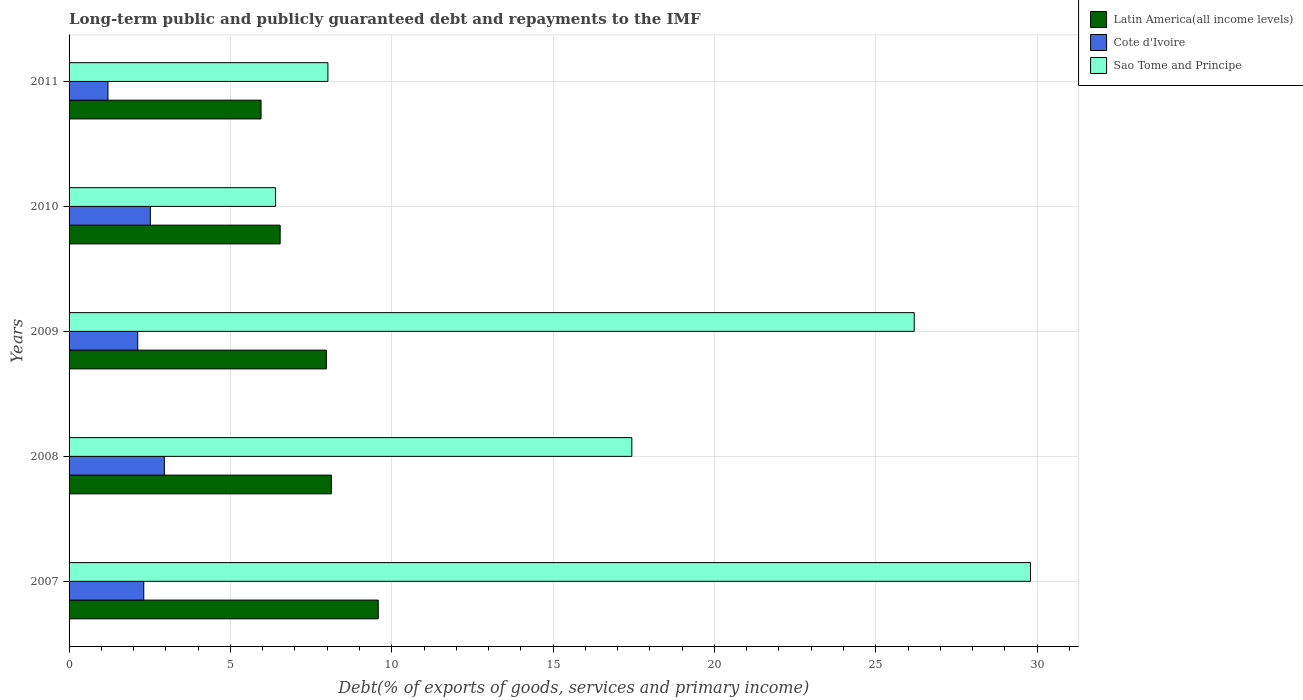How many different coloured bars are there?
Your answer should be very brief. 3. Are the number of bars per tick equal to the number of legend labels?
Provide a succinct answer. Yes. Are the number of bars on each tick of the Y-axis equal?
Provide a short and direct response. Yes. How many bars are there on the 2nd tick from the top?
Offer a very short reply. 3. How many bars are there on the 3rd tick from the bottom?
Ensure brevity in your answer.  3. What is the label of the 1st group of bars from the top?
Provide a succinct answer. 2011. In how many cases, is the number of bars for a given year not equal to the number of legend labels?
Offer a very short reply. 0. What is the debt and repayments in Sao Tome and Principe in 2009?
Make the answer very short. 26.19. Across all years, what is the maximum debt and repayments in Sao Tome and Principe?
Your response must be concise. 29.8. Across all years, what is the minimum debt and repayments in Cote d'Ivoire?
Provide a short and direct response. 1.21. In which year was the debt and repayments in Cote d'Ivoire maximum?
Offer a very short reply. 2008. In which year was the debt and repayments in Cote d'Ivoire minimum?
Your response must be concise. 2011. What is the total debt and repayments in Cote d'Ivoire in the graph?
Ensure brevity in your answer.  11.12. What is the difference between the debt and repayments in Latin America(all income levels) in 2007 and that in 2011?
Make the answer very short. 3.63. What is the difference between the debt and repayments in Latin America(all income levels) in 2009 and the debt and repayments in Cote d'Ivoire in 2007?
Ensure brevity in your answer.  5.66. What is the average debt and repayments in Cote d'Ivoire per year?
Keep it short and to the point. 2.22. In the year 2007, what is the difference between the debt and repayments in Cote d'Ivoire and debt and repayments in Sao Tome and Principe?
Ensure brevity in your answer.  -27.48. What is the ratio of the debt and repayments in Cote d'Ivoire in 2009 to that in 2011?
Provide a short and direct response. 1.77. Is the debt and repayments in Cote d'Ivoire in 2009 less than that in 2011?
Provide a short and direct response. No. What is the difference between the highest and the second highest debt and repayments in Sao Tome and Principe?
Ensure brevity in your answer.  3.6. What is the difference between the highest and the lowest debt and repayments in Latin America(all income levels)?
Your response must be concise. 3.63. What does the 2nd bar from the top in 2011 represents?
Keep it short and to the point. Cote d'Ivoire. What does the 3rd bar from the bottom in 2011 represents?
Your answer should be compact. Sao Tome and Principe. Is it the case that in every year, the sum of the debt and repayments in Sao Tome and Principe and debt and repayments in Latin America(all income levels) is greater than the debt and repayments in Cote d'Ivoire?
Give a very brief answer. Yes. How many years are there in the graph?
Offer a very short reply. 5. Does the graph contain grids?
Offer a terse response. Yes. How many legend labels are there?
Provide a short and direct response. 3. What is the title of the graph?
Offer a terse response. Long-term public and publicly guaranteed debt and repayments to the IMF. What is the label or title of the X-axis?
Ensure brevity in your answer.  Debt(% of exports of goods, services and primary income). What is the Debt(% of exports of goods, services and primary income) of Latin America(all income levels) in 2007?
Keep it short and to the point. 9.58. What is the Debt(% of exports of goods, services and primary income) in Cote d'Ivoire in 2007?
Keep it short and to the point. 2.31. What is the Debt(% of exports of goods, services and primary income) of Sao Tome and Principe in 2007?
Your answer should be compact. 29.8. What is the Debt(% of exports of goods, services and primary income) of Latin America(all income levels) in 2008?
Give a very brief answer. 8.13. What is the Debt(% of exports of goods, services and primary income) of Cote d'Ivoire in 2008?
Keep it short and to the point. 2.95. What is the Debt(% of exports of goods, services and primary income) in Sao Tome and Principe in 2008?
Keep it short and to the point. 17.44. What is the Debt(% of exports of goods, services and primary income) in Latin America(all income levels) in 2009?
Your answer should be compact. 7.97. What is the Debt(% of exports of goods, services and primary income) in Cote d'Ivoire in 2009?
Offer a very short reply. 2.13. What is the Debt(% of exports of goods, services and primary income) in Sao Tome and Principe in 2009?
Your answer should be compact. 26.19. What is the Debt(% of exports of goods, services and primary income) in Latin America(all income levels) in 2010?
Ensure brevity in your answer.  6.54. What is the Debt(% of exports of goods, services and primary income) in Cote d'Ivoire in 2010?
Provide a short and direct response. 2.52. What is the Debt(% of exports of goods, services and primary income) of Sao Tome and Principe in 2010?
Keep it short and to the point. 6.4. What is the Debt(% of exports of goods, services and primary income) in Latin America(all income levels) in 2011?
Your response must be concise. 5.95. What is the Debt(% of exports of goods, services and primary income) in Cote d'Ivoire in 2011?
Keep it short and to the point. 1.21. What is the Debt(% of exports of goods, services and primary income) in Sao Tome and Principe in 2011?
Provide a short and direct response. 8.02. Across all years, what is the maximum Debt(% of exports of goods, services and primary income) in Latin America(all income levels)?
Keep it short and to the point. 9.58. Across all years, what is the maximum Debt(% of exports of goods, services and primary income) in Cote d'Ivoire?
Offer a terse response. 2.95. Across all years, what is the maximum Debt(% of exports of goods, services and primary income) of Sao Tome and Principe?
Ensure brevity in your answer.  29.8. Across all years, what is the minimum Debt(% of exports of goods, services and primary income) in Latin America(all income levels)?
Your response must be concise. 5.95. Across all years, what is the minimum Debt(% of exports of goods, services and primary income) of Cote d'Ivoire?
Make the answer very short. 1.21. Across all years, what is the minimum Debt(% of exports of goods, services and primary income) in Sao Tome and Principe?
Offer a very short reply. 6.4. What is the total Debt(% of exports of goods, services and primary income) in Latin America(all income levels) in the graph?
Your response must be concise. 38.17. What is the total Debt(% of exports of goods, services and primary income) of Cote d'Ivoire in the graph?
Keep it short and to the point. 11.12. What is the total Debt(% of exports of goods, services and primary income) in Sao Tome and Principe in the graph?
Ensure brevity in your answer.  87.85. What is the difference between the Debt(% of exports of goods, services and primary income) of Latin America(all income levels) in 2007 and that in 2008?
Offer a terse response. 1.45. What is the difference between the Debt(% of exports of goods, services and primary income) in Cote d'Ivoire in 2007 and that in 2008?
Your response must be concise. -0.64. What is the difference between the Debt(% of exports of goods, services and primary income) of Sao Tome and Principe in 2007 and that in 2008?
Your answer should be very brief. 12.36. What is the difference between the Debt(% of exports of goods, services and primary income) of Latin America(all income levels) in 2007 and that in 2009?
Provide a short and direct response. 1.61. What is the difference between the Debt(% of exports of goods, services and primary income) in Cote d'Ivoire in 2007 and that in 2009?
Keep it short and to the point. 0.19. What is the difference between the Debt(% of exports of goods, services and primary income) of Sao Tome and Principe in 2007 and that in 2009?
Provide a succinct answer. 3.6. What is the difference between the Debt(% of exports of goods, services and primary income) in Latin America(all income levels) in 2007 and that in 2010?
Give a very brief answer. 3.04. What is the difference between the Debt(% of exports of goods, services and primary income) in Cote d'Ivoire in 2007 and that in 2010?
Offer a very short reply. -0.2. What is the difference between the Debt(% of exports of goods, services and primary income) in Sao Tome and Principe in 2007 and that in 2010?
Your response must be concise. 23.4. What is the difference between the Debt(% of exports of goods, services and primary income) of Latin America(all income levels) in 2007 and that in 2011?
Your response must be concise. 3.63. What is the difference between the Debt(% of exports of goods, services and primary income) in Cote d'Ivoire in 2007 and that in 2011?
Provide a short and direct response. 1.11. What is the difference between the Debt(% of exports of goods, services and primary income) in Sao Tome and Principe in 2007 and that in 2011?
Provide a succinct answer. 21.77. What is the difference between the Debt(% of exports of goods, services and primary income) of Latin America(all income levels) in 2008 and that in 2009?
Offer a very short reply. 0.15. What is the difference between the Debt(% of exports of goods, services and primary income) in Cote d'Ivoire in 2008 and that in 2009?
Your response must be concise. 0.83. What is the difference between the Debt(% of exports of goods, services and primary income) of Sao Tome and Principe in 2008 and that in 2009?
Provide a short and direct response. -8.75. What is the difference between the Debt(% of exports of goods, services and primary income) of Latin America(all income levels) in 2008 and that in 2010?
Keep it short and to the point. 1.59. What is the difference between the Debt(% of exports of goods, services and primary income) of Cote d'Ivoire in 2008 and that in 2010?
Provide a short and direct response. 0.44. What is the difference between the Debt(% of exports of goods, services and primary income) in Sao Tome and Principe in 2008 and that in 2010?
Keep it short and to the point. 11.04. What is the difference between the Debt(% of exports of goods, services and primary income) in Latin America(all income levels) in 2008 and that in 2011?
Offer a terse response. 2.18. What is the difference between the Debt(% of exports of goods, services and primary income) in Cote d'Ivoire in 2008 and that in 2011?
Your response must be concise. 1.75. What is the difference between the Debt(% of exports of goods, services and primary income) in Sao Tome and Principe in 2008 and that in 2011?
Give a very brief answer. 9.42. What is the difference between the Debt(% of exports of goods, services and primary income) in Latin America(all income levels) in 2009 and that in 2010?
Provide a succinct answer. 1.43. What is the difference between the Debt(% of exports of goods, services and primary income) in Cote d'Ivoire in 2009 and that in 2010?
Your response must be concise. -0.39. What is the difference between the Debt(% of exports of goods, services and primary income) of Sao Tome and Principe in 2009 and that in 2010?
Offer a terse response. 19.79. What is the difference between the Debt(% of exports of goods, services and primary income) in Latin America(all income levels) in 2009 and that in 2011?
Give a very brief answer. 2.02. What is the difference between the Debt(% of exports of goods, services and primary income) of Cote d'Ivoire in 2009 and that in 2011?
Provide a short and direct response. 0.92. What is the difference between the Debt(% of exports of goods, services and primary income) in Sao Tome and Principe in 2009 and that in 2011?
Your answer should be very brief. 18.17. What is the difference between the Debt(% of exports of goods, services and primary income) of Latin America(all income levels) in 2010 and that in 2011?
Offer a terse response. 0.59. What is the difference between the Debt(% of exports of goods, services and primary income) of Cote d'Ivoire in 2010 and that in 2011?
Your answer should be very brief. 1.31. What is the difference between the Debt(% of exports of goods, services and primary income) of Sao Tome and Principe in 2010 and that in 2011?
Your response must be concise. -1.62. What is the difference between the Debt(% of exports of goods, services and primary income) in Latin America(all income levels) in 2007 and the Debt(% of exports of goods, services and primary income) in Cote d'Ivoire in 2008?
Your answer should be very brief. 6.63. What is the difference between the Debt(% of exports of goods, services and primary income) of Latin America(all income levels) in 2007 and the Debt(% of exports of goods, services and primary income) of Sao Tome and Principe in 2008?
Provide a succinct answer. -7.86. What is the difference between the Debt(% of exports of goods, services and primary income) in Cote d'Ivoire in 2007 and the Debt(% of exports of goods, services and primary income) in Sao Tome and Principe in 2008?
Offer a terse response. -15.13. What is the difference between the Debt(% of exports of goods, services and primary income) in Latin America(all income levels) in 2007 and the Debt(% of exports of goods, services and primary income) in Cote d'Ivoire in 2009?
Your answer should be very brief. 7.45. What is the difference between the Debt(% of exports of goods, services and primary income) of Latin America(all income levels) in 2007 and the Debt(% of exports of goods, services and primary income) of Sao Tome and Principe in 2009?
Offer a very short reply. -16.61. What is the difference between the Debt(% of exports of goods, services and primary income) of Cote d'Ivoire in 2007 and the Debt(% of exports of goods, services and primary income) of Sao Tome and Principe in 2009?
Offer a terse response. -23.88. What is the difference between the Debt(% of exports of goods, services and primary income) in Latin America(all income levels) in 2007 and the Debt(% of exports of goods, services and primary income) in Cote d'Ivoire in 2010?
Provide a short and direct response. 7.06. What is the difference between the Debt(% of exports of goods, services and primary income) of Latin America(all income levels) in 2007 and the Debt(% of exports of goods, services and primary income) of Sao Tome and Principe in 2010?
Make the answer very short. 3.18. What is the difference between the Debt(% of exports of goods, services and primary income) in Cote d'Ivoire in 2007 and the Debt(% of exports of goods, services and primary income) in Sao Tome and Principe in 2010?
Your answer should be very brief. -4.08. What is the difference between the Debt(% of exports of goods, services and primary income) of Latin America(all income levels) in 2007 and the Debt(% of exports of goods, services and primary income) of Cote d'Ivoire in 2011?
Your response must be concise. 8.38. What is the difference between the Debt(% of exports of goods, services and primary income) of Latin America(all income levels) in 2007 and the Debt(% of exports of goods, services and primary income) of Sao Tome and Principe in 2011?
Offer a terse response. 1.56. What is the difference between the Debt(% of exports of goods, services and primary income) in Cote d'Ivoire in 2007 and the Debt(% of exports of goods, services and primary income) in Sao Tome and Principe in 2011?
Make the answer very short. -5.71. What is the difference between the Debt(% of exports of goods, services and primary income) in Latin America(all income levels) in 2008 and the Debt(% of exports of goods, services and primary income) in Cote d'Ivoire in 2009?
Make the answer very short. 6. What is the difference between the Debt(% of exports of goods, services and primary income) of Latin America(all income levels) in 2008 and the Debt(% of exports of goods, services and primary income) of Sao Tome and Principe in 2009?
Your answer should be very brief. -18.06. What is the difference between the Debt(% of exports of goods, services and primary income) in Cote d'Ivoire in 2008 and the Debt(% of exports of goods, services and primary income) in Sao Tome and Principe in 2009?
Ensure brevity in your answer.  -23.24. What is the difference between the Debt(% of exports of goods, services and primary income) of Latin America(all income levels) in 2008 and the Debt(% of exports of goods, services and primary income) of Cote d'Ivoire in 2010?
Offer a very short reply. 5.61. What is the difference between the Debt(% of exports of goods, services and primary income) in Latin America(all income levels) in 2008 and the Debt(% of exports of goods, services and primary income) in Sao Tome and Principe in 2010?
Give a very brief answer. 1.73. What is the difference between the Debt(% of exports of goods, services and primary income) in Cote d'Ivoire in 2008 and the Debt(% of exports of goods, services and primary income) in Sao Tome and Principe in 2010?
Offer a terse response. -3.45. What is the difference between the Debt(% of exports of goods, services and primary income) of Latin America(all income levels) in 2008 and the Debt(% of exports of goods, services and primary income) of Cote d'Ivoire in 2011?
Your answer should be very brief. 6.92. What is the difference between the Debt(% of exports of goods, services and primary income) of Latin America(all income levels) in 2008 and the Debt(% of exports of goods, services and primary income) of Sao Tome and Principe in 2011?
Provide a short and direct response. 0.11. What is the difference between the Debt(% of exports of goods, services and primary income) of Cote d'Ivoire in 2008 and the Debt(% of exports of goods, services and primary income) of Sao Tome and Principe in 2011?
Your response must be concise. -5.07. What is the difference between the Debt(% of exports of goods, services and primary income) in Latin America(all income levels) in 2009 and the Debt(% of exports of goods, services and primary income) in Cote d'Ivoire in 2010?
Your answer should be very brief. 5.46. What is the difference between the Debt(% of exports of goods, services and primary income) of Latin America(all income levels) in 2009 and the Debt(% of exports of goods, services and primary income) of Sao Tome and Principe in 2010?
Offer a terse response. 1.57. What is the difference between the Debt(% of exports of goods, services and primary income) of Cote d'Ivoire in 2009 and the Debt(% of exports of goods, services and primary income) of Sao Tome and Principe in 2010?
Provide a short and direct response. -4.27. What is the difference between the Debt(% of exports of goods, services and primary income) in Latin America(all income levels) in 2009 and the Debt(% of exports of goods, services and primary income) in Cote d'Ivoire in 2011?
Your answer should be very brief. 6.77. What is the difference between the Debt(% of exports of goods, services and primary income) in Latin America(all income levels) in 2009 and the Debt(% of exports of goods, services and primary income) in Sao Tome and Principe in 2011?
Give a very brief answer. -0.05. What is the difference between the Debt(% of exports of goods, services and primary income) of Cote d'Ivoire in 2009 and the Debt(% of exports of goods, services and primary income) of Sao Tome and Principe in 2011?
Make the answer very short. -5.89. What is the difference between the Debt(% of exports of goods, services and primary income) of Latin America(all income levels) in 2010 and the Debt(% of exports of goods, services and primary income) of Cote d'Ivoire in 2011?
Make the answer very short. 5.34. What is the difference between the Debt(% of exports of goods, services and primary income) in Latin America(all income levels) in 2010 and the Debt(% of exports of goods, services and primary income) in Sao Tome and Principe in 2011?
Give a very brief answer. -1.48. What is the difference between the Debt(% of exports of goods, services and primary income) of Cote d'Ivoire in 2010 and the Debt(% of exports of goods, services and primary income) of Sao Tome and Principe in 2011?
Your answer should be compact. -5.5. What is the average Debt(% of exports of goods, services and primary income) of Latin America(all income levels) per year?
Your response must be concise. 7.63. What is the average Debt(% of exports of goods, services and primary income) in Cote d'Ivoire per year?
Provide a succinct answer. 2.22. What is the average Debt(% of exports of goods, services and primary income) of Sao Tome and Principe per year?
Your answer should be compact. 17.57. In the year 2007, what is the difference between the Debt(% of exports of goods, services and primary income) in Latin America(all income levels) and Debt(% of exports of goods, services and primary income) in Cote d'Ivoire?
Offer a terse response. 7.27. In the year 2007, what is the difference between the Debt(% of exports of goods, services and primary income) in Latin America(all income levels) and Debt(% of exports of goods, services and primary income) in Sao Tome and Principe?
Ensure brevity in your answer.  -20.21. In the year 2007, what is the difference between the Debt(% of exports of goods, services and primary income) of Cote d'Ivoire and Debt(% of exports of goods, services and primary income) of Sao Tome and Principe?
Make the answer very short. -27.48. In the year 2008, what is the difference between the Debt(% of exports of goods, services and primary income) of Latin America(all income levels) and Debt(% of exports of goods, services and primary income) of Cote d'Ivoire?
Offer a terse response. 5.17. In the year 2008, what is the difference between the Debt(% of exports of goods, services and primary income) of Latin America(all income levels) and Debt(% of exports of goods, services and primary income) of Sao Tome and Principe?
Provide a short and direct response. -9.31. In the year 2008, what is the difference between the Debt(% of exports of goods, services and primary income) in Cote d'Ivoire and Debt(% of exports of goods, services and primary income) in Sao Tome and Principe?
Offer a terse response. -14.49. In the year 2009, what is the difference between the Debt(% of exports of goods, services and primary income) in Latin America(all income levels) and Debt(% of exports of goods, services and primary income) in Cote d'Ivoire?
Give a very brief answer. 5.85. In the year 2009, what is the difference between the Debt(% of exports of goods, services and primary income) in Latin America(all income levels) and Debt(% of exports of goods, services and primary income) in Sao Tome and Principe?
Provide a succinct answer. -18.22. In the year 2009, what is the difference between the Debt(% of exports of goods, services and primary income) of Cote d'Ivoire and Debt(% of exports of goods, services and primary income) of Sao Tome and Principe?
Offer a terse response. -24.06. In the year 2010, what is the difference between the Debt(% of exports of goods, services and primary income) of Latin America(all income levels) and Debt(% of exports of goods, services and primary income) of Cote d'Ivoire?
Offer a very short reply. 4.02. In the year 2010, what is the difference between the Debt(% of exports of goods, services and primary income) of Latin America(all income levels) and Debt(% of exports of goods, services and primary income) of Sao Tome and Principe?
Offer a very short reply. 0.14. In the year 2010, what is the difference between the Debt(% of exports of goods, services and primary income) of Cote d'Ivoire and Debt(% of exports of goods, services and primary income) of Sao Tome and Principe?
Make the answer very short. -3.88. In the year 2011, what is the difference between the Debt(% of exports of goods, services and primary income) in Latin America(all income levels) and Debt(% of exports of goods, services and primary income) in Cote d'Ivoire?
Your answer should be compact. 4.74. In the year 2011, what is the difference between the Debt(% of exports of goods, services and primary income) in Latin America(all income levels) and Debt(% of exports of goods, services and primary income) in Sao Tome and Principe?
Provide a short and direct response. -2.07. In the year 2011, what is the difference between the Debt(% of exports of goods, services and primary income) of Cote d'Ivoire and Debt(% of exports of goods, services and primary income) of Sao Tome and Principe?
Make the answer very short. -6.82. What is the ratio of the Debt(% of exports of goods, services and primary income) in Latin America(all income levels) in 2007 to that in 2008?
Your answer should be very brief. 1.18. What is the ratio of the Debt(% of exports of goods, services and primary income) in Cote d'Ivoire in 2007 to that in 2008?
Provide a short and direct response. 0.78. What is the ratio of the Debt(% of exports of goods, services and primary income) of Sao Tome and Principe in 2007 to that in 2008?
Offer a terse response. 1.71. What is the ratio of the Debt(% of exports of goods, services and primary income) in Latin America(all income levels) in 2007 to that in 2009?
Your answer should be compact. 1.2. What is the ratio of the Debt(% of exports of goods, services and primary income) in Cote d'Ivoire in 2007 to that in 2009?
Provide a succinct answer. 1.09. What is the ratio of the Debt(% of exports of goods, services and primary income) in Sao Tome and Principe in 2007 to that in 2009?
Give a very brief answer. 1.14. What is the ratio of the Debt(% of exports of goods, services and primary income) of Latin America(all income levels) in 2007 to that in 2010?
Offer a terse response. 1.46. What is the ratio of the Debt(% of exports of goods, services and primary income) in Cote d'Ivoire in 2007 to that in 2010?
Ensure brevity in your answer.  0.92. What is the ratio of the Debt(% of exports of goods, services and primary income) in Sao Tome and Principe in 2007 to that in 2010?
Your response must be concise. 4.66. What is the ratio of the Debt(% of exports of goods, services and primary income) of Latin America(all income levels) in 2007 to that in 2011?
Provide a short and direct response. 1.61. What is the ratio of the Debt(% of exports of goods, services and primary income) of Cote d'Ivoire in 2007 to that in 2011?
Ensure brevity in your answer.  1.92. What is the ratio of the Debt(% of exports of goods, services and primary income) of Sao Tome and Principe in 2007 to that in 2011?
Provide a short and direct response. 3.71. What is the ratio of the Debt(% of exports of goods, services and primary income) in Latin America(all income levels) in 2008 to that in 2009?
Provide a short and direct response. 1.02. What is the ratio of the Debt(% of exports of goods, services and primary income) in Cote d'Ivoire in 2008 to that in 2009?
Provide a short and direct response. 1.39. What is the ratio of the Debt(% of exports of goods, services and primary income) of Sao Tome and Principe in 2008 to that in 2009?
Offer a very short reply. 0.67. What is the ratio of the Debt(% of exports of goods, services and primary income) in Latin America(all income levels) in 2008 to that in 2010?
Your answer should be very brief. 1.24. What is the ratio of the Debt(% of exports of goods, services and primary income) of Cote d'Ivoire in 2008 to that in 2010?
Keep it short and to the point. 1.17. What is the ratio of the Debt(% of exports of goods, services and primary income) of Sao Tome and Principe in 2008 to that in 2010?
Your answer should be compact. 2.73. What is the ratio of the Debt(% of exports of goods, services and primary income) of Latin America(all income levels) in 2008 to that in 2011?
Your answer should be very brief. 1.37. What is the ratio of the Debt(% of exports of goods, services and primary income) in Cote d'Ivoire in 2008 to that in 2011?
Your answer should be compact. 2.45. What is the ratio of the Debt(% of exports of goods, services and primary income) in Sao Tome and Principe in 2008 to that in 2011?
Provide a short and direct response. 2.17. What is the ratio of the Debt(% of exports of goods, services and primary income) in Latin America(all income levels) in 2009 to that in 2010?
Provide a short and direct response. 1.22. What is the ratio of the Debt(% of exports of goods, services and primary income) in Cote d'Ivoire in 2009 to that in 2010?
Provide a succinct answer. 0.85. What is the ratio of the Debt(% of exports of goods, services and primary income) in Sao Tome and Principe in 2009 to that in 2010?
Provide a succinct answer. 4.09. What is the ratio of the Debt(% of exports of goods, services and primary income) of Latin America(all income levels) in 2009 to that in 2011?
Offer a terse response. 1.34. What is the ratio of the Debt(% of exports of goods, services and primary income) of Cote d'Ivoire in 2009 to that in 2011?
Provide a short and direct response. 1.77. What is the ratio of the Debt(% of exports of goods, services and primary income) of Sao Tome and Principe in 2009 to that in 2011?
Make the answer very short. 3.27. What is the ratio of the Debt(% of exports of goods, services and primary income) in Latin America(all income levels) in 2010 to that in 2011?
Your answer should be very brief. 1.1. What is the ratio of the Debt(% of exports of goods, services and primary income) of Cote d'Ivoire in 2010 to that in 2011?
Your answer should be compact. 2.09. What is the ratio of the Debt(% of exports of goods, services and primary income) of Sao Tome and Principe in 2010 to that in 2011?
Offer a very short reply. 0.8. What is the difference between the highest and the second highest Debt(% of exports of goods, services and primary income) in Latin America(all income levels)?
Offer a terse response. 1.45. What is the difference between the highest and the second highest Debt(% of exports of goods, services and primary income) of Cote d'Ivoire?
Make the answer very short. 0.44. What is the difference between the highest and the second highest Debt(% of exports of goods, services and primary income) in Sao Tome and Principe?
Provide a short and direct response. 3.6. What is the difference between the highest and the lowest Debt(% of exports of goods, services and primary income) in Latin America(all income levels)?
Ensure brevity in your answer.  3.63. What is the difference between the highest and the lowest Debt(% of exports of goods, services and primary income) in Cote d'Ivoire?
Give a very brief answer. 1.75. What is the difference between the highest and the lowest Debt(% of exports of goods, services and primary income) in Sao Tome and Principe?
Make the answer very short. 23.4. 